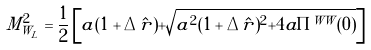Convert formula to latex. <formula><loc_0><loc_0><loc_500><loc_500>M _ { W _ { L } } ^ { 2 } = \frac { 1 } { 2 } \left [ a ( 1 + \Delta \hat { r } ) + \sqrt { a ^ { 2 } ( 1 + \Delta \hat { r } ) ^ { 2 } + 4 a \Pi ^ { W W } ( 0 ) } \right ]</formula> 